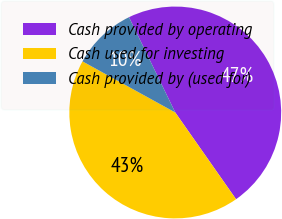Convert chart. <chart><loc_0><loc_0><loc_500><loc_500><pie_chart><fcel>Cash provided by operating<fcel>Cash used for investing<fcel>Cash provided by (used for)<nl><fcel>47.46%<fcel>42.74%<fcel>9.79%<nl></chart> 